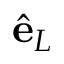<formula> <loc_0><loc_0><loc_500><loc_500>\hat { e } _ { L }</formula> 